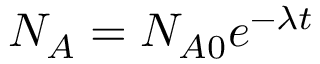Convert formula to latex. <formula><loc_0><loc_0><loc_500><loc_500>N _ { A } = N _ { A 0 } e ^ { - { \lambda } t }</formula> 